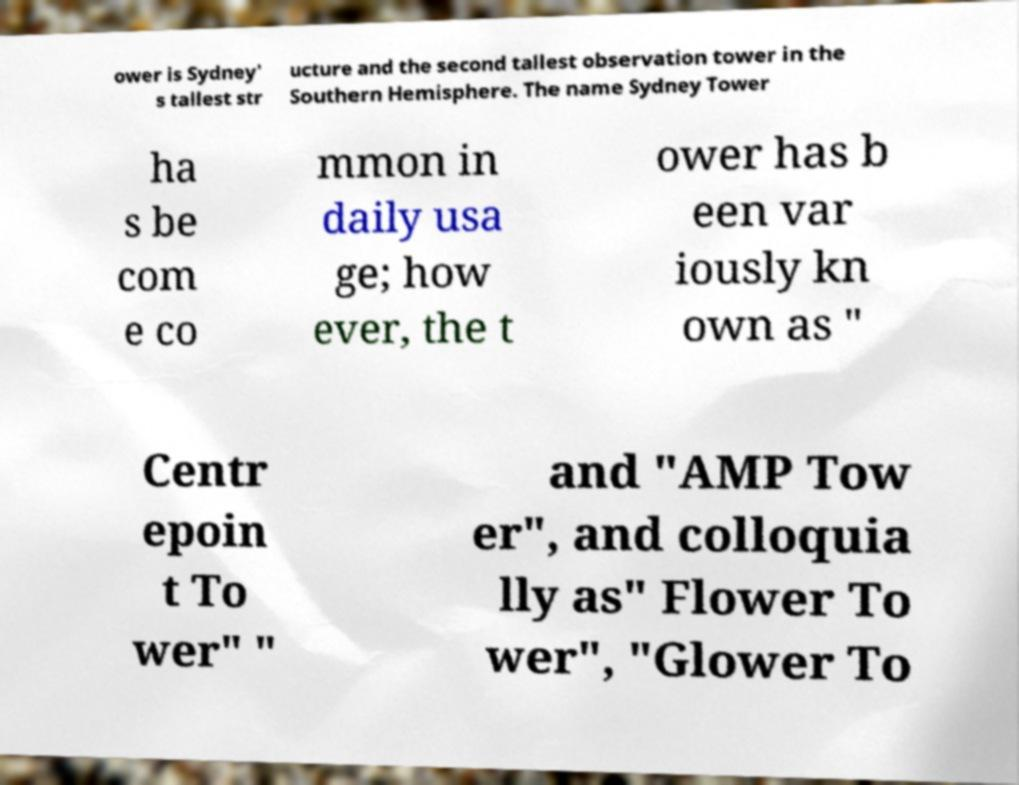What messages or text are displayed in this image? I need them in a readable, typed format. ower is Sydney' s tallest str ucture and the second tallest observation tower in the Southern Hemisphere. The name Sydney Tower ha s be com e co mmon in daily usa ge; how ever, the t ower has b een var iously kn own as " Centr epoin t To wer" " and "AMP Tow er", and colloquia lly as" Flower To wer", "Glower To 